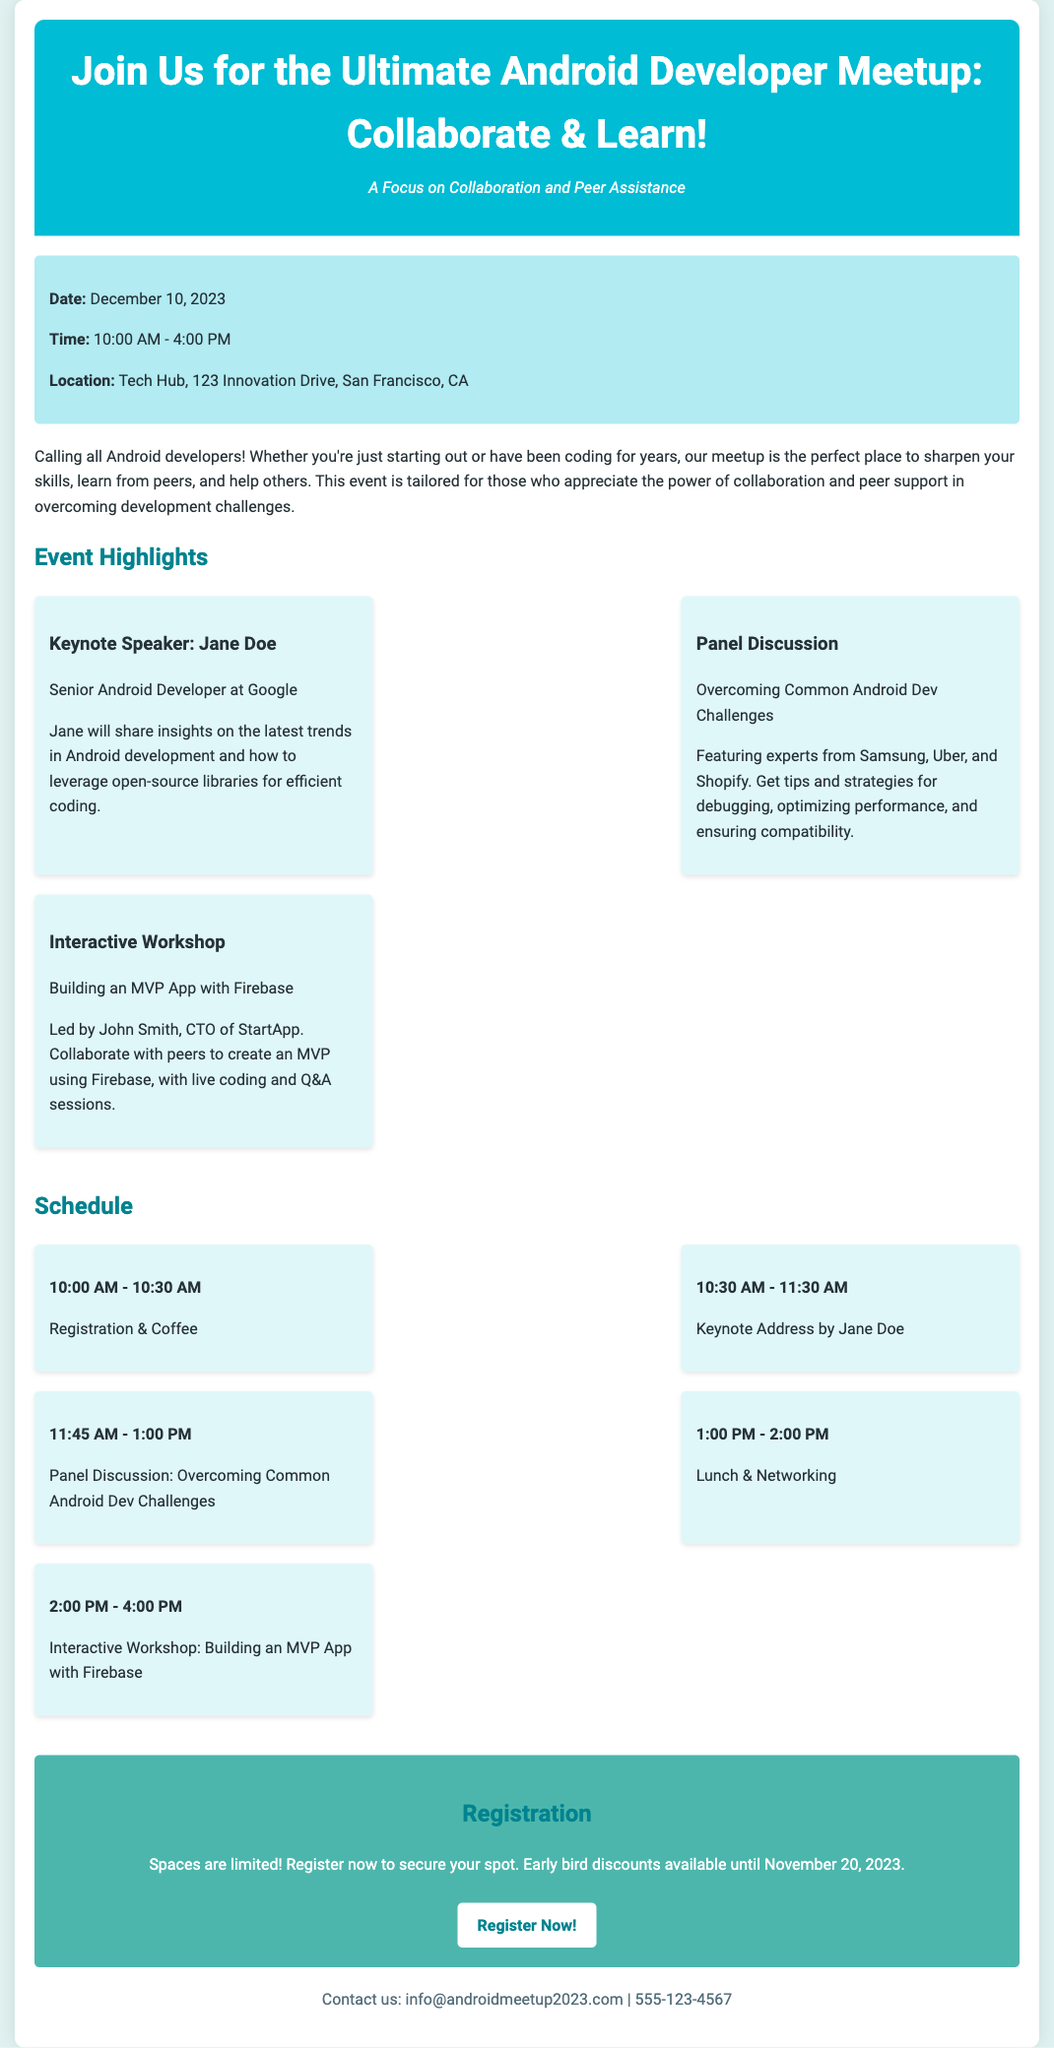What is the date of the meetup? The date of the meetup is explicitly mentioned in the event details section of the document.
Answer: December 10, 2023 Who is the keynote speaker? The name of the keynote speaker is presented in the event highlights section.
Answer: Jane Doe What time does the interactive workshop start? The schedule outlines the starting time of each segment of the event, including the workshop.
Answer: 2:00 PM Which company is John Smith associated with? The document specifies John Smith's title and the company he represents within the workshop details.
Answer: StartApp How long is the lunch break? The schedule provides details about the duration of the lunch period.
Answer: 1 hour What topic will be discussed in the panel discussion? The topic for the panel discussion is clearly stated within the highlights section.
Answer: Overcoming Common Android Dev Challenges What is the registration deadline for early bird discounts? The registration section indicates the specific date for early bird discounts.
Answer: November 20, 2023 Where is the meetup taking place? The location of the meetup is listed in the event details of the document.
Answer: Tech Hub, 123 Innovation Drive, San Francisco, CA How many companies are represented in the panel discussion? The highlights mention the number of companies participating in the panel without requiring any external knowledge.
Answer: Three 